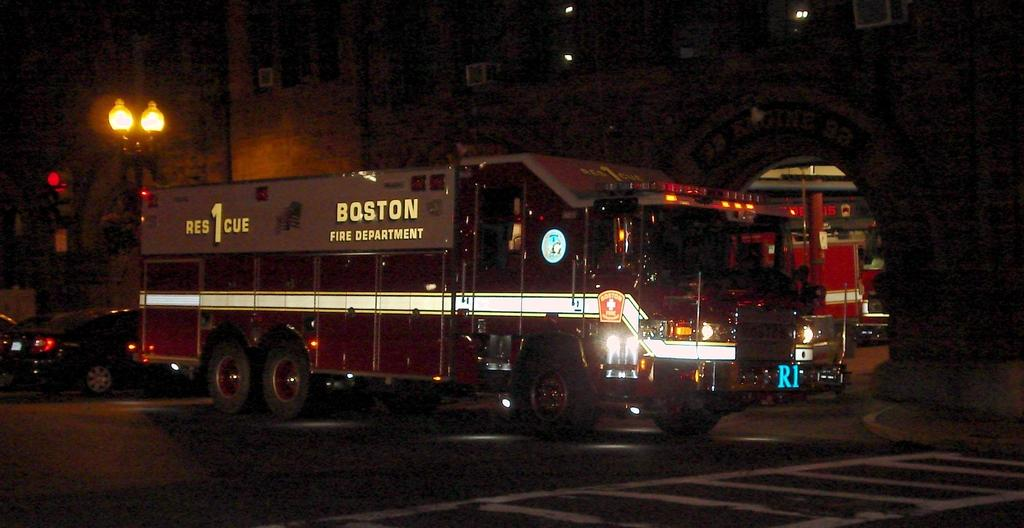What is happening on the road in the image? There are vehicles on the road in the image. What can be seen in the distance behind the vehicles? There are buildings and lights visible in the background of the image. Can you describe the unspecified objects in the background? Unfortunately, the provided facts do not specify the nature of the unspecified objects in the background. How many tomatoes are hanging from the zinc roof in the image? There are no tomatoes or zinc roofs present in the image. 